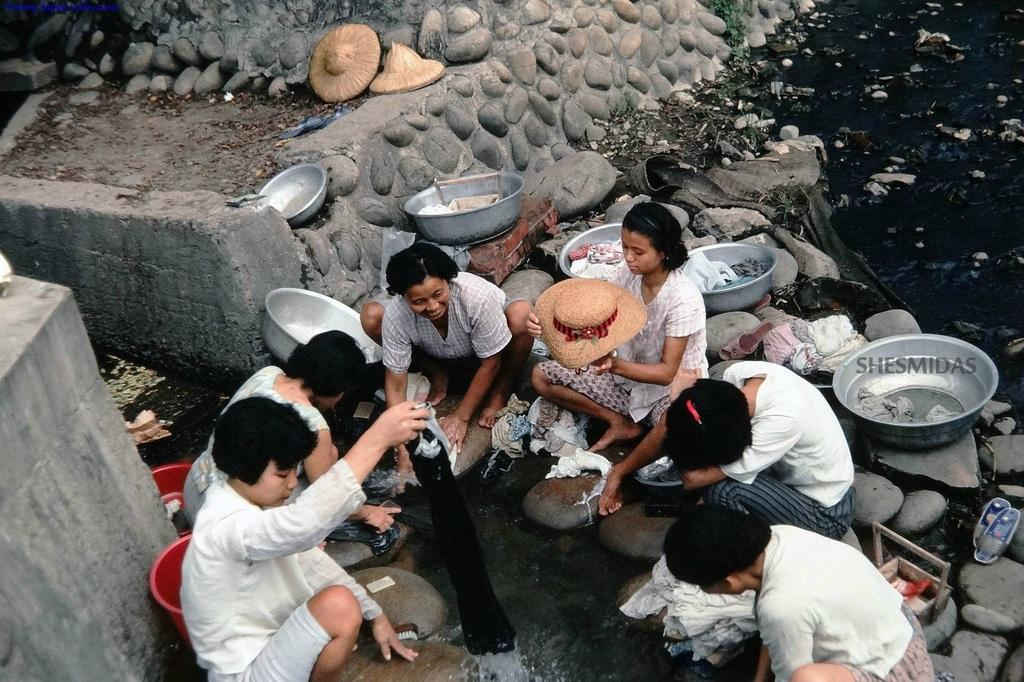What are the people in the center of the image doing? The people in the center of the image are sitting and holding objects. What can be seen in the background of the image? There are stones, water, buckets, and clothes visible in the background of the image. Can you tell me what question the ghost is asking in the image? There is no ghost present in the image, so it is not possible to answer that question. 